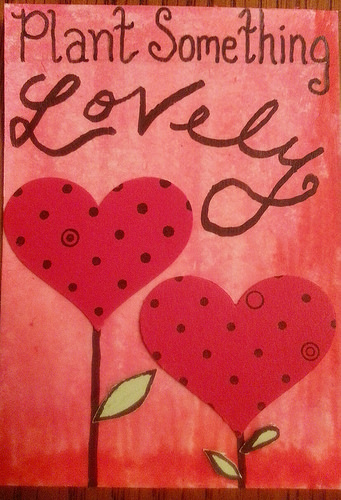<image>
Is the heart on the stem? Yes. Looking at the image, I can see the heart is positioned on top of the stem, with the stem providing support. Where is the heart in relation to the card? Is it on the card? Yes. Looking at the image, I can see the heart is positioned on top of the card, with the card providing support. 